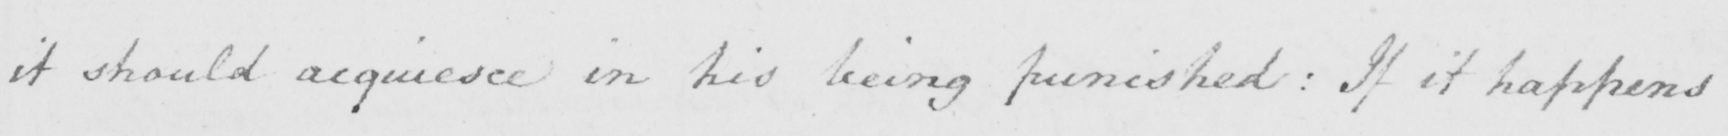Please provide the text content of this handwritten line. it should acquiesce in his being punished : If it happens 